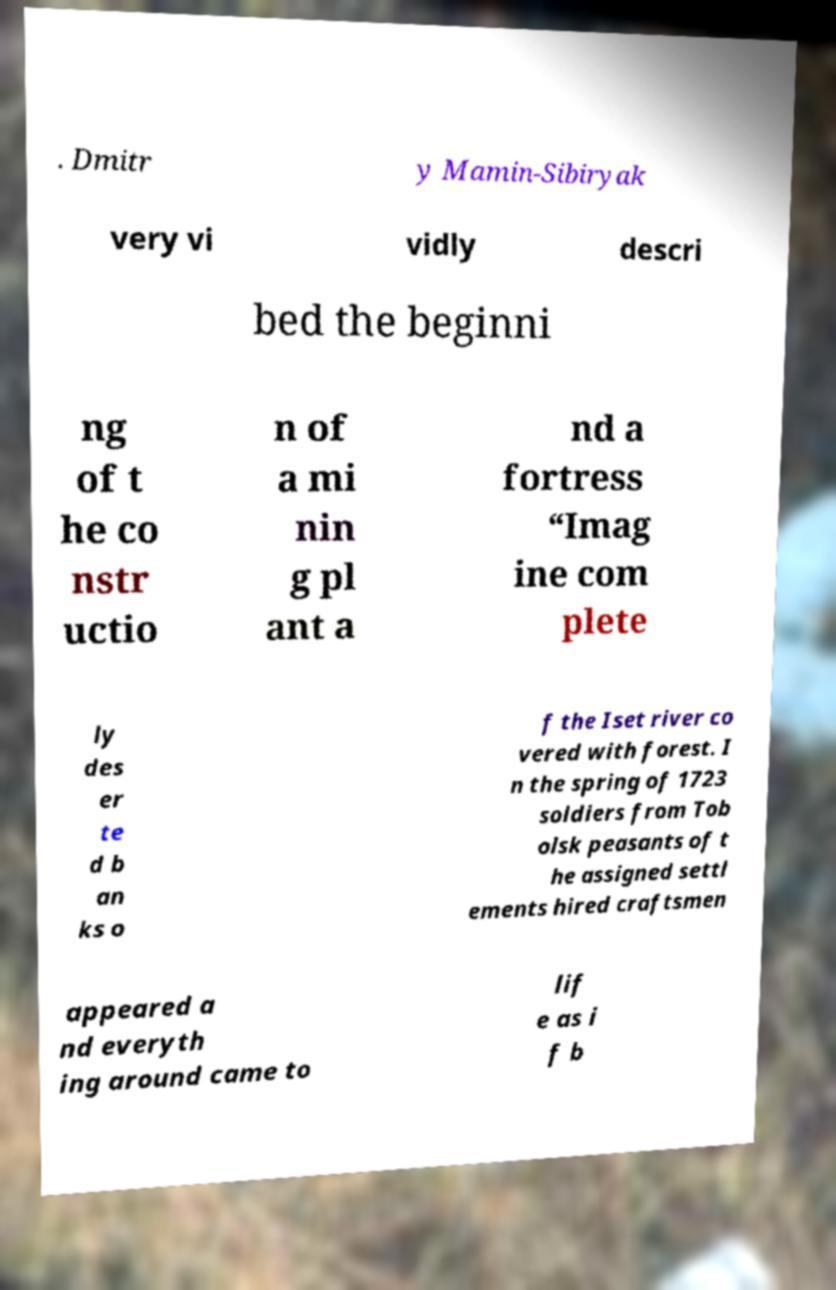For documentation purposes, I need the text within this image transcribed. Could you provide that? . Dmitr y Mamin-Sibiryak very vi vidly descri bed the beginni ng of t he co nstr uctio n of a mi nin g pl ant a nd a fortress “Imag ine com plete ly des er te d b an ks o f the Iset river co vered with forest. I n the spring of 1723 soldiers from Tob olsk peasants of t he assigned settl ements hired craftsmen appeared a nd everyth ing around came to lif e as i f b 